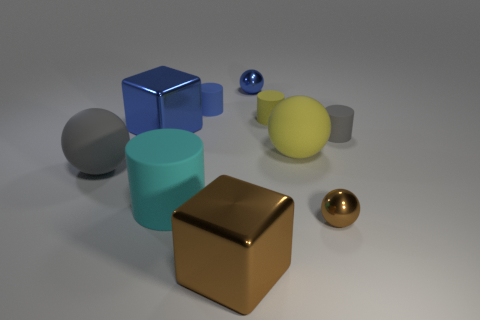Subtract 1 balls. How many balls are left? 3 Subtract all cylinders. How many objects are left? 6 Add 9 blue spheres. How many blue spheres are left? 10 Add 4 big gray matte objects. How many big gray matte objects exist? 5 Subtract 1 brown cubes. How many objects are left? 9 Subtract all blue cylinders. Subtract all small blue rubber things. How many objects are left? 8 